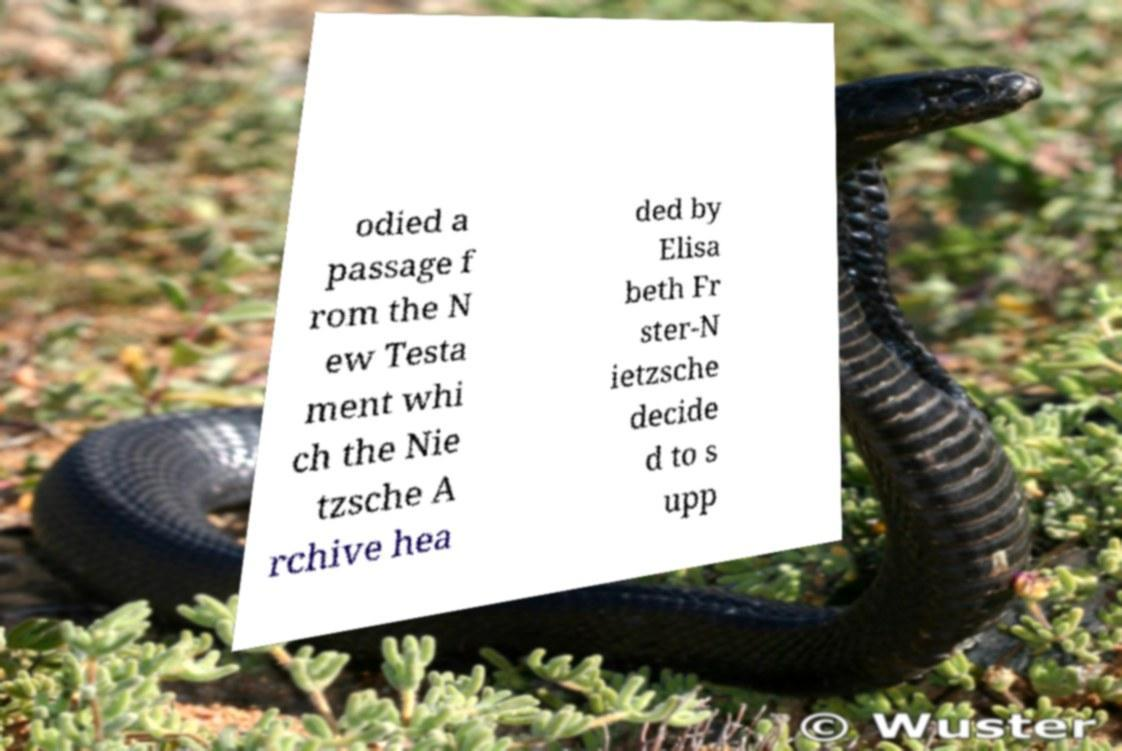I need the written content from this picture converted into text. Can you do that? odied a passage f rom the N ew Testa ment whi ch the Nie tzsche A rchive hea ded by Elisa beth Fr ster-N ietzsche decide d to s upp 